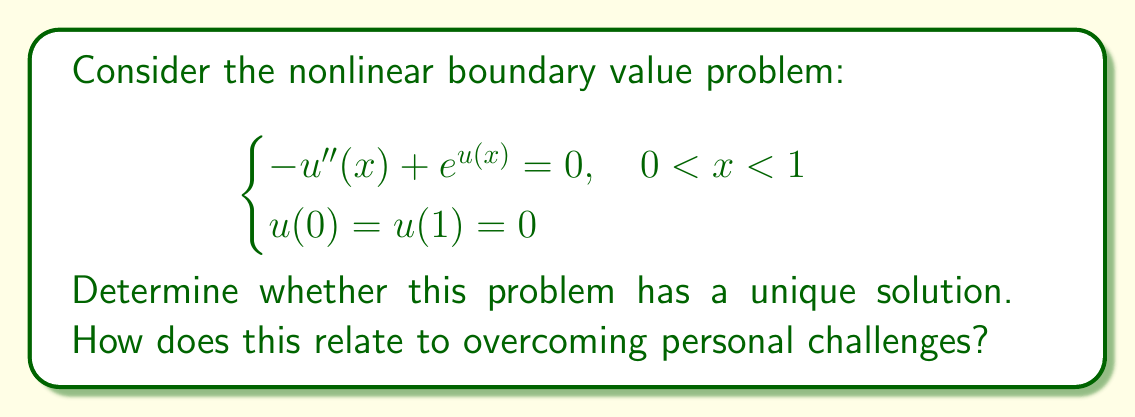Provide a solution to this math problem. To determine the existence and uniqueness of solutions for this nonlinear boundary value problem, we'll use the following steps:

1) First, we note that this problem is in the form:
   $$-u'' + f(u) = 0$$
   where $f(u) = e^u$.

2) For existence, we can use the method of upper and lower solutions. Let's define:
   $\alpha(x) = 0$ (lower solution)
   $\beta(x) = \ln(1 + x(1-x))$ (upper solution)

3) We can verify that:
   $\alpha(0) = \alpha(1) = 0$
   $\beta(0) = \beta(1) = 0$
   $\alpha(x) \leq \beta(x)$ for $x \in [0,1]$

4) Also, $-\alpha'' + f(\alpha) = e^0 = 1 > 0$
   and $-\beta'' + f(\beta) = -\frac{2}{1+x(1-x)} + 1 + x(1-x) < 0$

5) These conditions ensure the existence of at least one solution $u(x)$ such that $\alpha(x) \leq u(x) \leq \beta(x)$.

6) For uniqueness, we note that $f'(u) = e^u > 0$ for all $u$. This means $f(u)$ is strictly increasing.

7) The strict monotonicity of $f(u)$ ensures the uniqueness of the solution.

Relating to overcoming personal challenges:
Just as this problem has a unique solution that exists between lower and upper bounds, personal growth often involves finding a unique path forward within the constraints of our current abilities (lower bound) and our aspirations (upper bound). The process of solving this problem, moving from uncertainty to a definite solution, parallels the journey of overcoming shyness and building confidence.
Answer: The problem has a unique solution. 